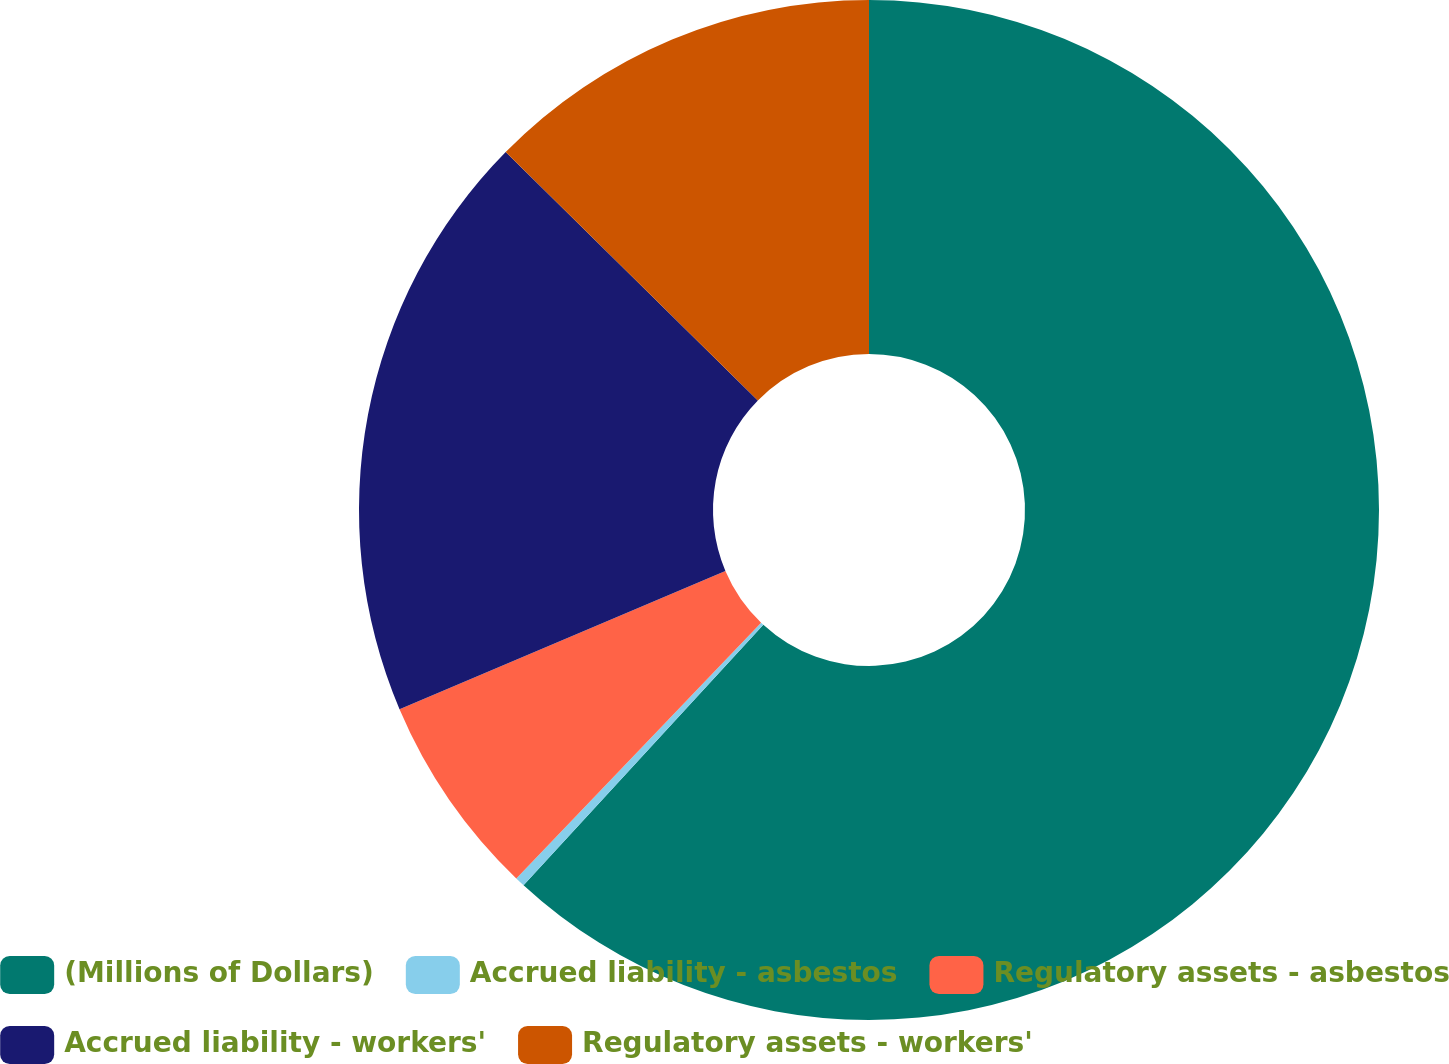<chart> <loc_0><loc_0><loc_500><loc_500><pie_chart><fcel>(Millions of Dollars)<fcel>Accrued liability - asbestos<fcel>Regulatory assets - asbestos<fcel>Accrued liability - workers'<fcel>Regulatory assets - workers'<nl><fcel>61.85%<fcel>0.31%<fcel>6.46%<fcel>18.77%<fcel>12.62%<nl></chart> 